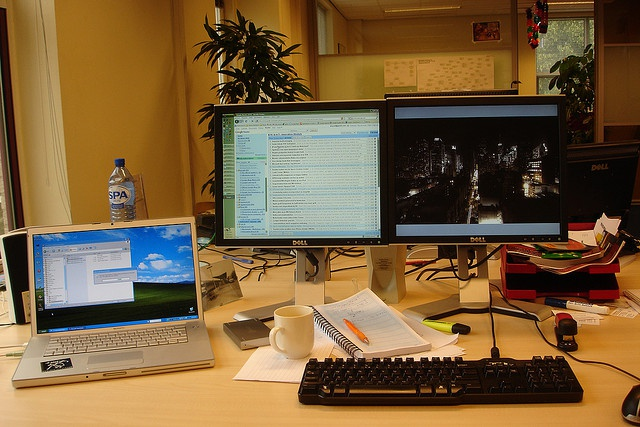Describe the objects in this image and their specific colors. I can see laptop in olive, black, tan, and darkgray tones, tv in olive, black, gray, and maroon tones, tv in olive, darkgray, lightgray, black, and gray tones, keyboard in olive, black, maroon, and brown tones, and potted plant in olive, black, and maroon tones in this image. 